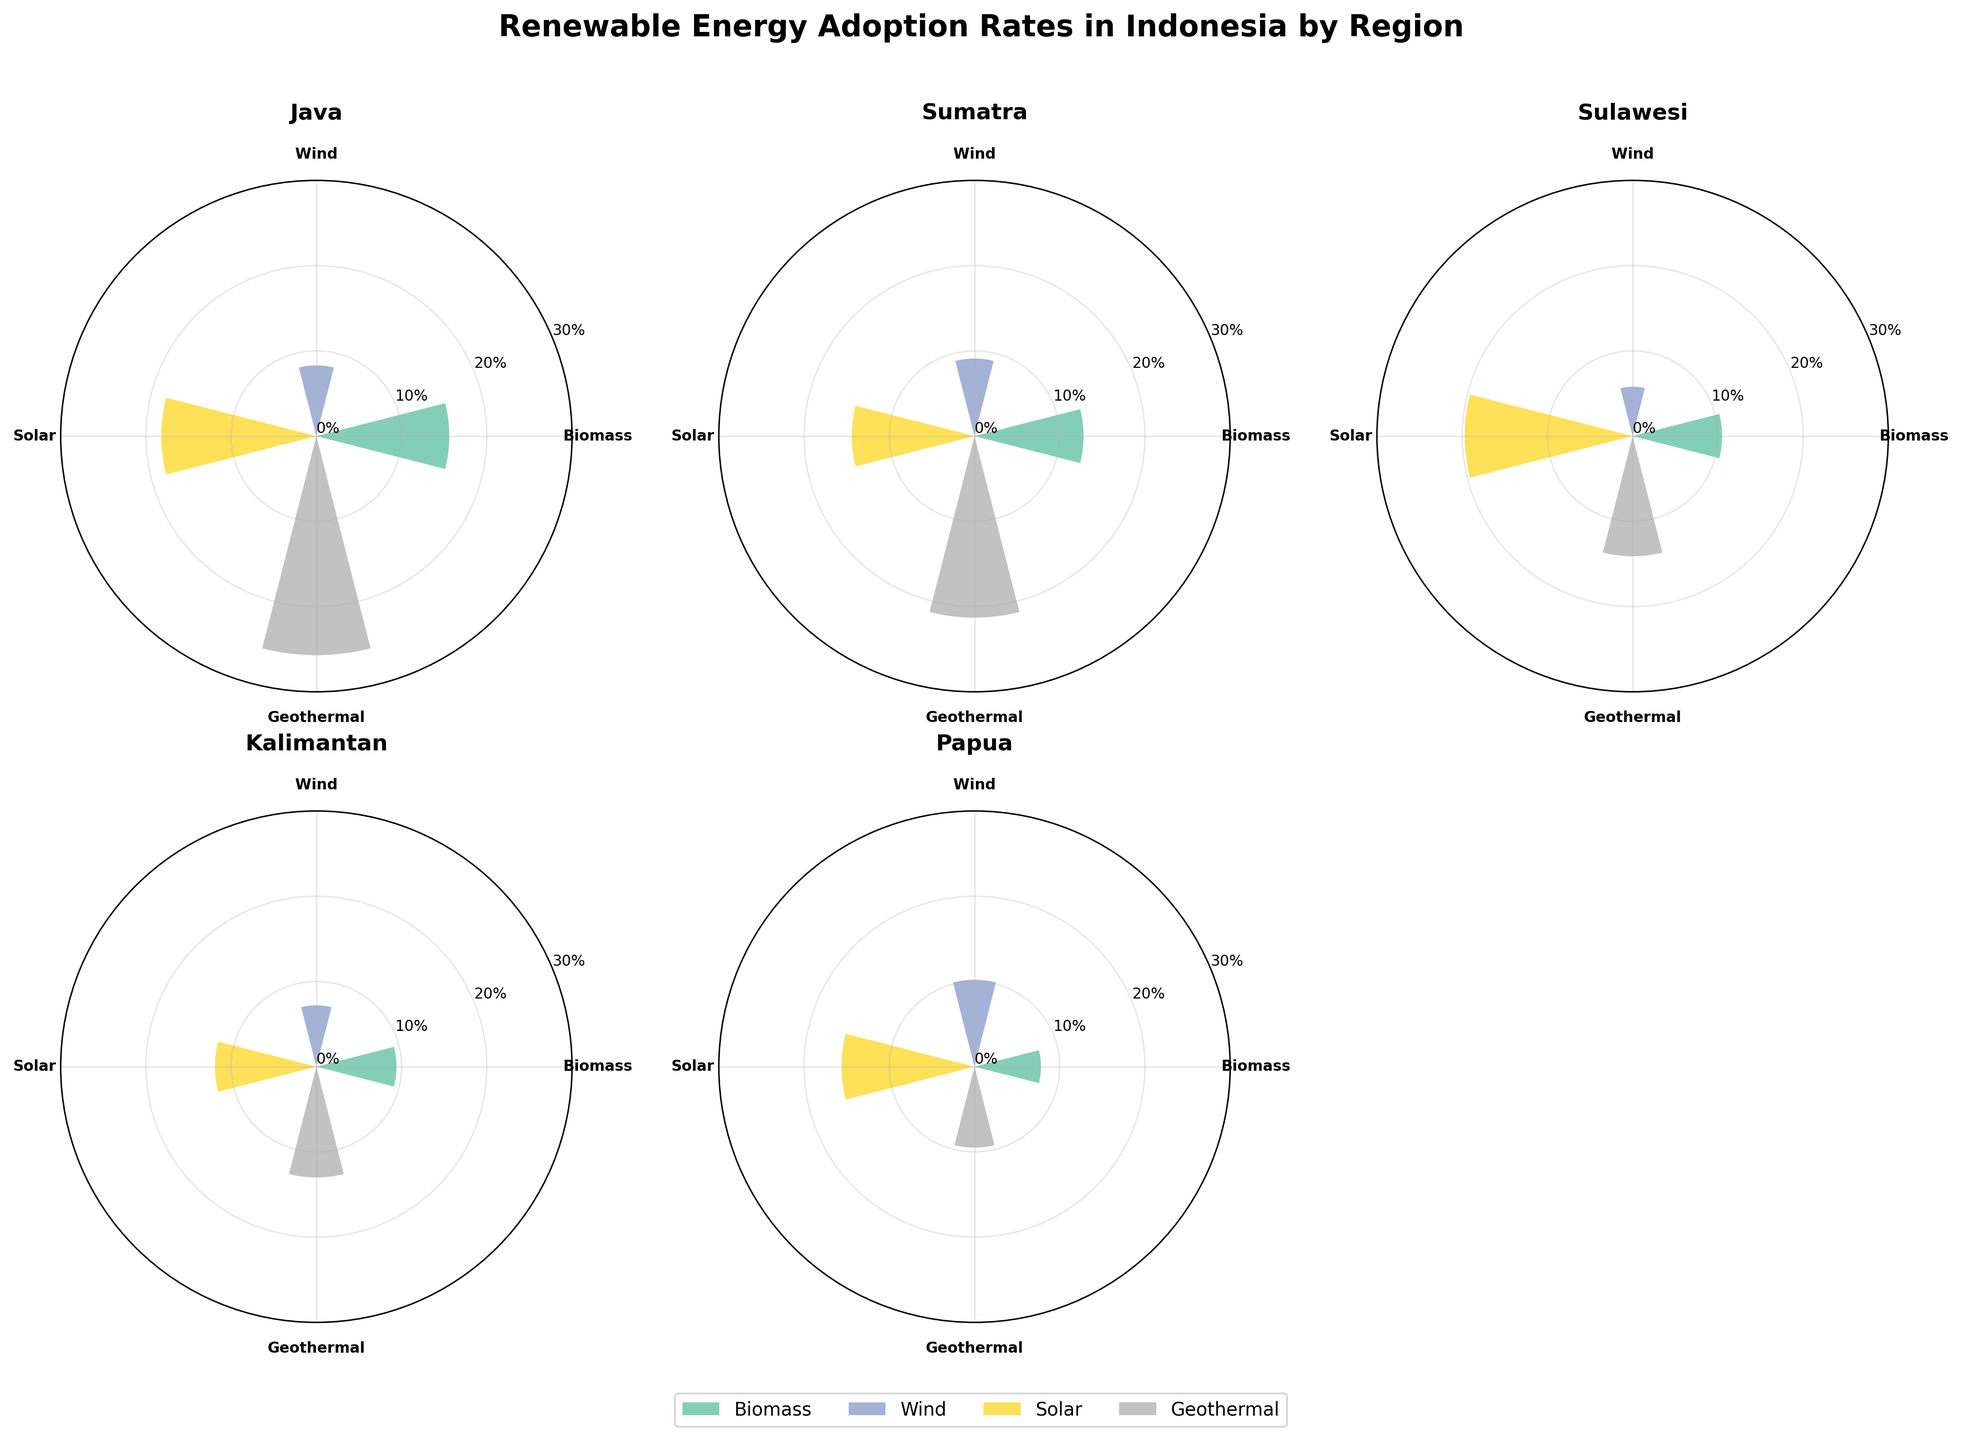Which region has the highest adoption rate of biomass energy? By looking at the bars representing biomass energy (typically the one labeled as "Biomass"), we can compare their heights across all regions. The tallest bar indicates the highest adoption rate. Java has the highest bar for biomass energy.
Answer: Java What is the combined adoption rate of wind energy in Sumatra and Sulawesi? Sumatra has a wind adoption rate of 9.1% and Sulawesi has a wind adoption rate of 5.8%. Adding these two percentages gives us 9.1% + 5.8% = 14.9%.
Answer: 14.9% In which region is solar energy adoption higher, Kalimantan or Papua? By comparing the bars representing solar energy (labeled "Solar") in both Kalimantan and Papua, we see that Papua's bar is taller than Kalimantan's. Therefore, Papua has a higher solar energy adoption rate.
Answer: Papua Which region has the smallest range between its highest and lowest adoption rate among the energy types? For each region, calculate the difference between the highest and lowest adoption rates. Java: 25.7% - 8.3% = 17.4%, Sumatra: 21.3% - 9.1% = 12.2%, Sulawesi: 19.7% - 5.8% = 13.9%, Kalimantan: 13.0% - 7.2% = 5.8%, Papua: 15.6% - 7.8% = 7.8%. Kalimantan has the smallest range.
Answer: Kalimantan Which energy type has the most consistent adoption rates across all regions? To determine this, we need to observe bars for each energy type across all regions. Geothermal generally has bars in a similar height range across regions (mostly above 9% but below 26%).
Answer: Geothermal What is the polar angle step between each energy type in the plot? Given that the polar plot covers 360 degrees (2*pi radians) and there are 4 energy types evenly distributed, the angle step is calculated as 360/4 = 90 degrees (or pi/2 radians).
Answer: 90 degrees How much higher is the geothermal energy adoption rate in Java compared to Papua? Java has a geothermal adoption rate of 25.7%, and Papua has a rate of 9.5%. Subtract the two percentages: 25.7% - 9.5% = 16.2%.
Answer: 16.2% Which region has the highest average adoption rate across all energy types? Calculate the average adoption rate for each region: Java (15.6+8.3+18.2+25.7)/4 = 17%, Sumatra (12.8+9.1+14.4+21.3)/4 = 14.4%, Sulawesi (10.5+5.8+19.7+14.1)/4 = 12.525%, Kalimantan (9.4+7.2+11.9+13.0)/4 = 10.375%, Papua (7.8+10.2+15.6+9.5)/4 = 10.775%. Java has the highest average.
Answer: Java Which regions have wind energy adoption rates below 8%? Observe the bar heights for wind energy (labeled "Wind") across all regions. Kalimantan (7.2%) and Sulawesi (5.8%) have bars below 8%.
Answer: Kalimantan, Sulawesi 